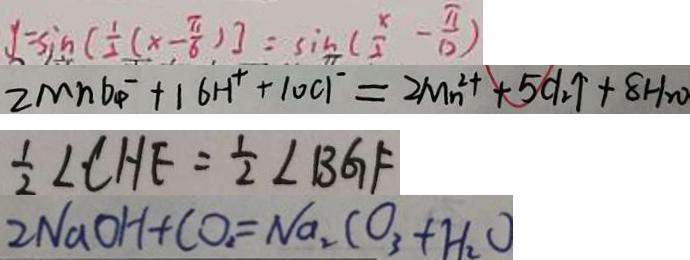<formula> <loc_0><loc_0><loc_500><loc_500>y = \sin [ \frac { 1 } { 2 } ( x - \frac { \pi } { 6 } ) ] = \sin ( \frac { x } { 2 } - \frac { \pi } { 1 2 } ) 
 2 M n O ^ { - } _ { 4 } + 1 6 H ^ { + } + 1 0 c 1 ^ { - } = 2 M n ^ { 2 + } + 5 C l _ { 2 } \uparrow + 8 H _ { 2 } 0 
 \frac { 1 } { 2 } \angle C H F = \frac { 1 } { 2 } \angle B G F 
 2 N a O H + C O _ { 2 } = N a _ { 2 } C O _ { 3 } + H _ { 2 } O</formula> 